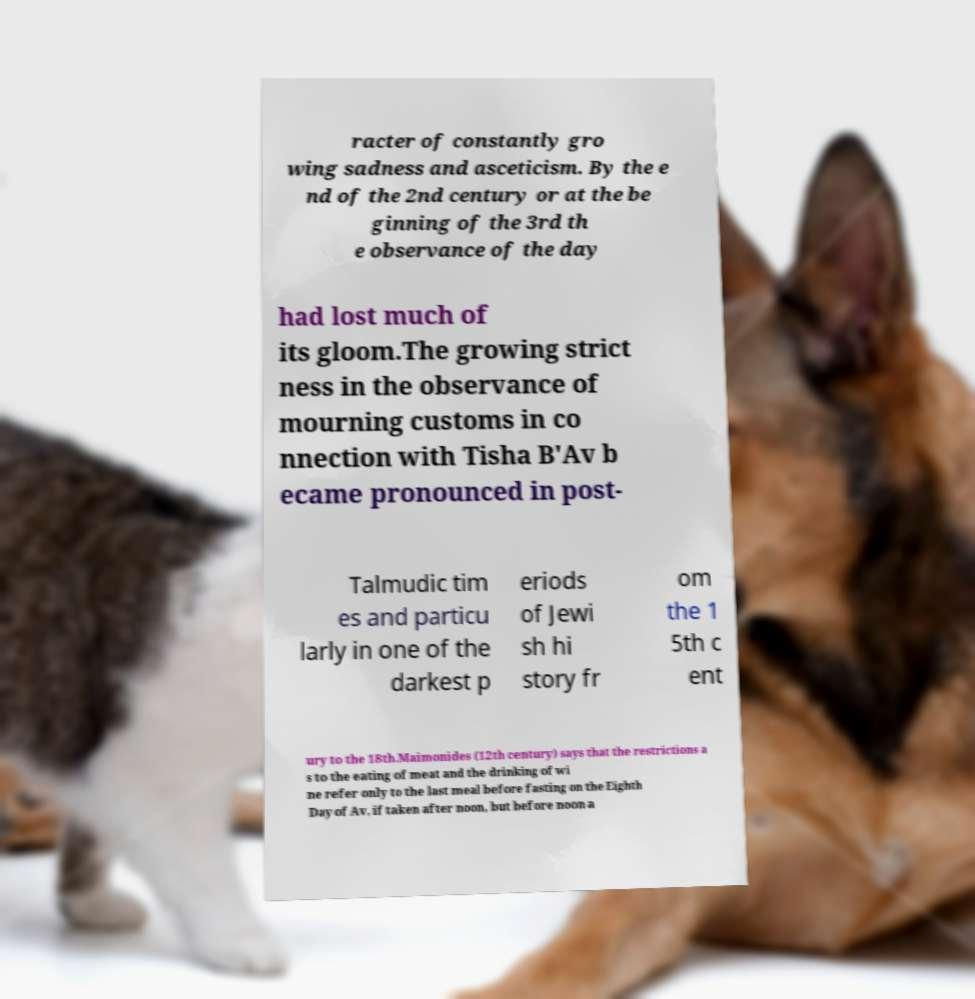There's text embedded in this image that I need extracted. Can you transcribe it verbatim? racter of constantly gro wing sadness and asceticism. By the e nd of the 2nd century or at the be ginning of the 3rd th e observance of the day had lost much of its gloom.The growing strict ness in the observance of mourning customs in co nnection with Tisha B'Av b ecame pronounced in post- Talmudic tim es and particu larly in one of the darkest p eriods of Jewi sh hi story fr om the 1 5th c ent ury to the 18th.Maimonides (12th century) says that the restrictions a s to the eating of meat and the drinking of wi ne refer only to the last meal before fasting on the Eighth Day of Av, if taken after noon, but before noon a 